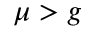Convert formula to latex. <formula><loc_0><loc_0><loc_500><loc_500>\mu > g</formula> 